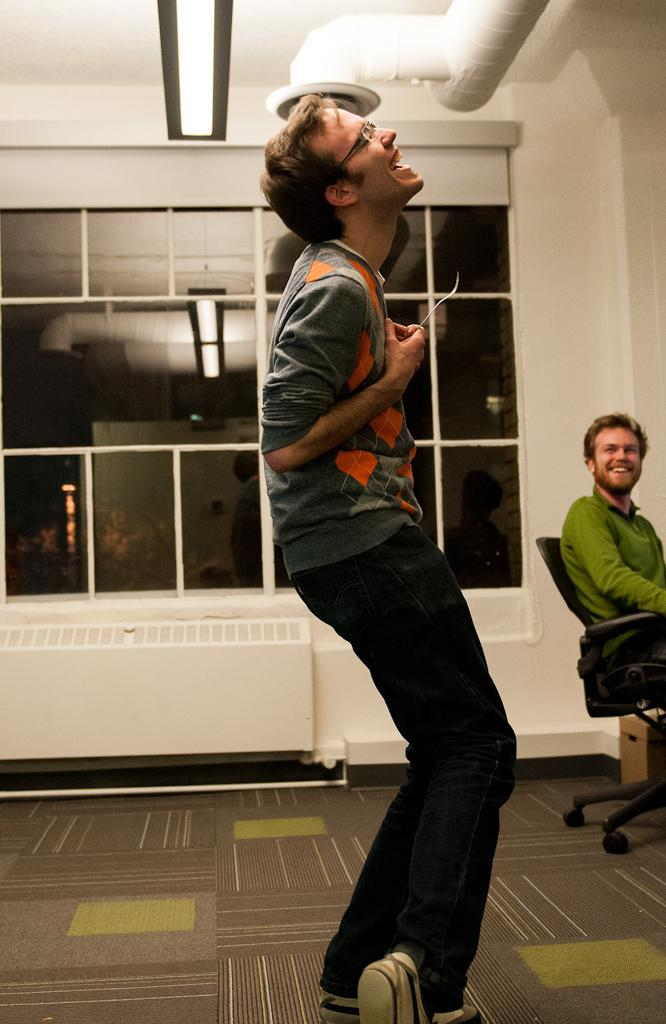What is the man in the foreground of the image doing? The man in the foreground of the image is standing and laughing. What is the other man in the image doing? The other man in the image is sitting in a chair and smiling. What can be seen in the background of the image? There is a glass window and a wall in the background of the image. What date is circled on the calendar in the image? There is no calendar present in the image. How many ants can be seen crawling on the wall in the image? There are no ants visible in the image; only the man standing, the man sitting, and the background elements are present. 